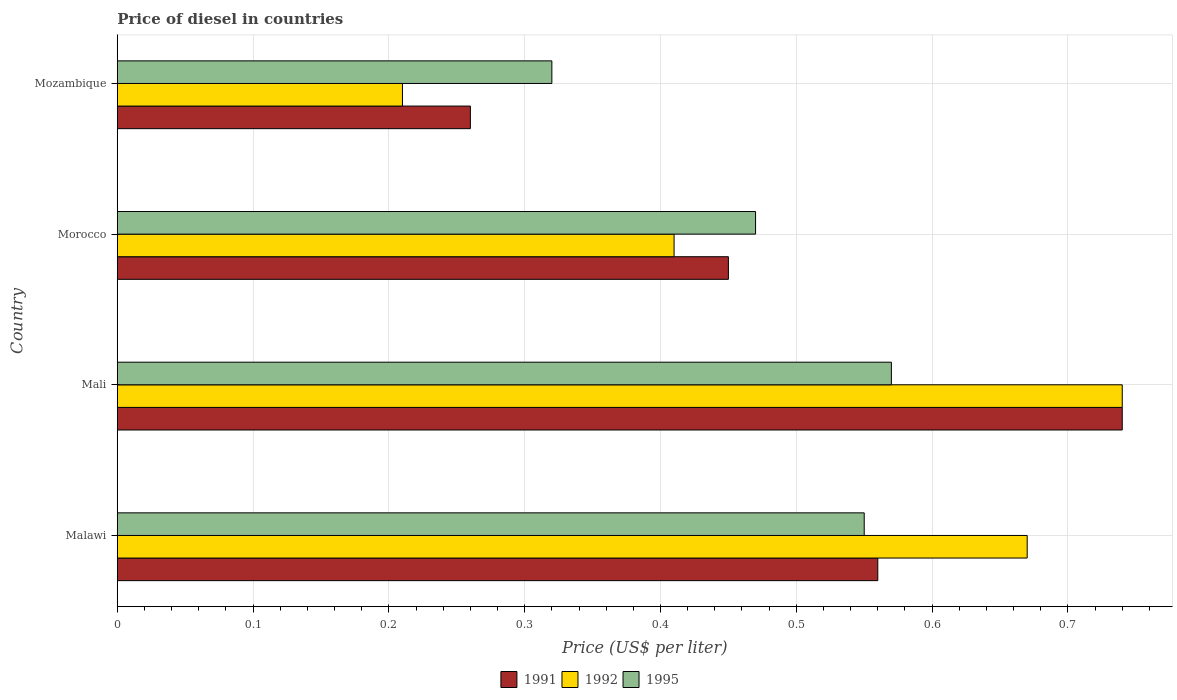Are the number of bars per tick equal to the number of legend labels?
Your answer should be compact. Yes. Are the number of bars on each tick of the Y-axis equal?
Your answer should be compact. Yes. How many bars are there on the 4th tick from the top?
Give a very brief answer. 3. What is the label of the 1st group of bars from the top?
Your answer should be compact. Mozambique. In how many cases, is the number of bars for a given country not equal to the number of legend labels?
Offer a terse response. 0. What is the price of diesel in 1995 in Malawi?
Give a very brief answer. 0.55. Across all countries, what is the maximum price of diesel in 1995?
Keep it short and to the point. 0.57. Across all countries, what is the minimum price of diesel in 1992?
Give a very brief answer. 0.21. In which country was the price of diesel in 1991 maximum?
Offer a very short reply. Mali. In which country was the price of diesel in 1995 minimum?
Ensure brevity in your answer.  Mozambique. What is the total price of diesel in 1992 in the graph?
Give a very brief answer. 2.03. What is the difference between the price of diesel in 1992 in Malawi and that in Morocco?
Your answer should be compact. 0.26. What is the difference between the price of diesel in 1991 in Morocco and the price of diesel in 1995 in Mozambique?
Give a very brief answer. 0.13. What is the average price of diesel in 1992 per country?
Your answer should be compact. 0.51. What is the difference between the price of diesel in 1992 and price of diesel in 1991 in Malawi?
Provide a succinct answer. 0.11. What is the ratio of the price of diesel in 1992 in Morocco to that in Mozambique?
Keep it short and to the point. 1.95. Is the price of diesel in 1995 in Morocco less than that in Mozambique?
Your response must be concise. No. What is the difference between the highest and the second highest price of diesel in 1995?
Ensure brevity in your answer.  0.02. What is the difference between the highest and the lowest price of diesel in 1991?
Offer a terse response. 0.48. In how many countries, is the price of diesel in 1995 greater than the average price of diesel in 1995 taken over all countries?
Offer a terse response. 2. Is the sum of the price of diesel in 1995 in Malawi and Morocco greater than the maximum price of diesel in 1992 across all countries?
Give a very brief answer. Yes. What does the 2nd bar from the top in Morocco represents?
Keep it short and to the point. 1992. What does the 1st bar from the bottom in Mozambique represents?
Provide a short and direct response. 1991. Is it the case that in every country, the sum of the price of diesel in 1991 and price of diesel in 1992 is greater than the price of diesel in 1995?
Offer a terse response. Yes. How many countries are there in the graph?
Keep it short and to the point. 4. Where does the legend appear in the graph?
Your response must be concise. Bottom center. How many legend labels are there?
Offer a very short reply. 3. What is the title of the graph?
Give a very brief answer. Price of diesel in countries. Does "1999" appear as one of the legend labels in the graph?
Offer a very short reply. No. What is the label or title of the X-axis?
Give a very brief answer. Price (US$ per liter). What is the label or title of the Y-axis?
Offer a terse response. Country. What is the Price (US$ per liter) of 1991 in Malawi?
Offer a terse response. 0.56. What is the Price (US$ per liter) of 1992 in Malawi?
Give a very brief answer. 0.67. What is the Price (US$ per liter) in 1995 in Malawi?
Your answer should be very brief. 0.55. What is the Price (US$ per liter) of 1991 in Mali?
Give a very brief answer. 0.74. What is the Price (US$ per liter) of 1992 in Mali?
Your response must be concise. 0.74. What is the Price (US$ per liter) in 1995 in Mali?
Offer a very short reply. 0.57. What is the Price (US$ per liter) in 1991 in Morocco?
Provide a succinct answer. 0.45. What is the Price (US$ per liter) of 1992 in Morocco?
Make the answer very short. 0.41. What is the Price (US$ per liter) of 1995 in Morocco?
Provide a succinct answer. 0.47. What is the Price (US$ per liter) in 1991 in Mozambique?
Ensure brevity in your answer.  0.26. What is the Price (US$ per liter) in 1992 in Mozambique?
Your answer should be compact. 0.21. What is the Price (US$ per liter) in 1995 in Mozambique?
Offer a very short reply. 0.32. Across all countries, what is the maximum Price (US$ per liter) in 1991?
Ensure brevity in your answer.  0.74. Across all countries, what is the maximum Price (US$ per liter) of 1992?
Your answer should be compact. 0.74. Across all countries, what is the maximum Price (US$ per liter) in 1995?
Provide a short and direct response. 0.57. Across all countries, what is the minimum Price (US$ per liter) in 1991?
Offer a very short reply. 0.26. Across all countries, what is the minimum Price (US$ per liter) of 1992?
Your answer should be very brief. 0.21. Across all countries, what is the minimum Price (US$ per liter) of 1995?
Keep it short and to the point. 0.32. What is the total Price (US$ per liter) in 1991 in the graph?
Offer a very short reply. 2.01. What is the total Price (US$ per liter) in 1992 in the graph?
Offer a very short reply. 2.03. What is the total Price (US$ per liter) of 1995 in the graph?
Your answer should be very brief. 1.91. What is the difference between the Price (US$ per liter) in 1991 in Malawi and that in Mali?
Offer a very short reply. -0.18. What is the difference between the Price (US$ per liter) in 1992 in Malawi and that in Mali?
Make the answer very short. -0.07. What is the difference between the Price (US$ per liter) in 1995 in Malawi and that in Mali?
Offer a terse response. -0.02. What is the difference between the Price (US$ per liter) of 1991 in Malawi and that in Morocco?
Your answer should be very brief. 0.11. What is the difference between the Price (US$ per liter) in 1992 in Malawi and that in Morocco?
Your answer should be compact. 0.26. What is the difference between the Price (US$ per liter) in 1995 in Malawi and that in Morocco?
Make the answer very short. 0.08. What is the difference between the Price (US$ per liter) in 1991 in Malawi and that in Mozambique?
Give a very brief answer. 0.3. What is the difference between the Price (US$ per liter) in 1992 in Malawi and that in Mozambique?
Your answer should be compact. 0.46. What is the difference between the Price (US$ per liter) of 1995 in Malawi and that in Mozambique?
Your answer should be compact. 0.23. What is the difference between the Price (US$ per liter) of 1991 in Mali and that in Morocco?
Your answer should be compact. 0.29. What is the difference between the Price (US$ per liter) of 1992 in Mali and that in Morocco?
Make the answer very short. 0.33. What is the difference between the Price (US$ per liter) of 1991 in Mali and that in Mozambique?
Make the answer very short. 0.48. What is the difference between the Price (US$ per liter) of 1992 in Mali and that in Mozambique?
Make the answer very short. 0.53. What is the difference between the Price (US$ per liter) in 1991 in Morocco and that in Mozambique?
Your response must be concise. 0.19. What is the difference between the Price (US$ per liter) in 1992 in Morocco and that in Mozambique?
Your response must be concise. 0.2. What is the difference between the Price (US$ per liter) of 1991 in Malawi and the Price (US$ per liter) of 1992 in Mali?
Your response must be concise. -0.18. What is the difference between the Price (US$ per liter) in 1991 in Malawi and the Price (US$ per liter) in 1995 in Mali?
Your answer should be very brief. -0.01. What is the difference between the Price (US$ per liter) in 1991 in Malawi and the Price (US$ per liter) in 1992 in Morocco?
Provide a succinct answer. 0.15. What is the difference between the Price (US$ per liter) of 1991 in Malawi and the Price (US$ per liter) of 1995 in Morocco?
Offer a very short reply. 0.09. What is the difference between the Price (US$ per liter) in 1992 in Malawi and the Price (US$ per liter) in 1995 in Morocco?
Give a very brief answer. 0.2. What is the difference between the Price (US$ per liter) of 1991 in Malawi and the Price (US$ per liter) of 1995 in Mozambique?
Offer a very short reply. 0.24. What is the difference between the Price (US$ per liter) of 1992 in Malawi and the Price (US$ per liter) of 1995 in Mozambique?
Provide a succinct answer. 0.35. What is the difference between the Price (US$ per liter) of 1991 in Mali and the Price (US$ per liter) of 1992 in Morocco?
Your response must be concise. 0.33. What is the difference between the Price (US$ per liter) in 1991 in Mali and the Price (US$ per liter) in 1995 in Morocco?
Offer a terse response. 0.27. What is the difference between the Price (US$ per liter) in 1992 in Mali and the Price (US$ per liter) in 1995 in Morocco?
Your answer should be very brief. 0.27. What is the difference between the Price (US$ per liter) in 1991 in Mali and the Price (US$ per liter) in 1992 in Mozambique?
Offer a terse response. 0.53. What is the difference between the Price (US$ per liter) in 1991 in Mali and the Price (US$ per liter) in 1995 in Mozambique?
Keep it short and to the point. 0.42. What is the difference between the Price (US$ per liter) of 1992 in Mali and the Price (US$ per liter) of 1995 in Mozambique?
Provide a succinct answer. 0.42. What is the difference between the Price (US$ per liter) of 1991 in Morocco and the Price (US$ per liter) of 1992 in Mozambique?
Your answer should be compact. 0.24. What is the difference between the Price (US$ per liter) in 1991 in Morocco and the Price (US$ per liter) in 1995 in Mozambique?
Offer a very short reply. 0.13. What is the difference between the Price (US$ per liter) of 1992 in Morocco and the Price (US$ per liter) of 1995 in Mozambique?
Your response must be concise. 0.09. What is the average Price (US$ per liter) of 1991 per country?
Offer a terse response. 0.5. What is the average Price (US$ per liter) of 1992 per country?
Ensure brevity in your answer.  0.51. What is the average Price (US$ per liter) of 1995 per country?
Give a very brief answer. 0.48. What is the difference between the Price (US$ per liter) of 1991 and Price (US$ per liter) of 1992 in Malawi?
Your answer should be compact. -0.11. What is the difference between the Price (US$ per liter) in 1992 and Price (US$ per liter) in 1995 in Malawi?
Offer a terse response. 0.12. What is the difference between the Price (US$ per liter) of 1991 and Price (US$ per liter) of 1992 in Mali?
Ensure brevity in your answer.  0. What is the difference between the Price (US$ per liter) of 1991 and Price (US$ per liter) of 1995 in Mali?
Ensure brevity in your answer.  0.17. What is the difference between the Price (US$ per liter) in 1992 and Price (US$ per liter) in 1995 in Mali?
Provide a short and direct response. 0.17. What is the difference between the Price (US$ per liter) of 1991 and Price (US$ per liter) of 1992 in Morocco?
Your answer should be very brief. 0.04. What is the difference between the Price (US$ per liter) in 1991 and Price (US$ per liter) in 1995 in Morocco?
Ensure brevity in your answer.  -0.02. What is the difference between the Price (US$ per liter) of 1992 and Price (US$ per liter) of 1995 in Morocco?
Provide a short and direct response. -0.06. What is the difference between the Price (US$ per liter) of 1991 and Price (US$ per liter) of 1995 in Mozambique?
Provide a short and direct response. -0.06. What is the difference between the Price (US$ per liter) of 1992 and Price (US$ per liter) of 1995 in Mozambique?
Keep it short and to the point. -0.11. What is the ratio of the Price (US$ per liter) in 1991 in Malawi to that in Mali?
Your answer should be compact. 0.76. What is the ratio of the Price (US$ per liter) of 1992 in Malawi to that in Mali?
Keep it short and to the point. 0.91. What is the ratio of the Price (US$ per liter) of 1995 in Malawi to that in Mali?
Offer a terse response. 0.96. What is the ratio of the Price (US$ per liter) in 1991 in Malawi to that in Morocco?
Give a very brief answer. 1.24. What is the ratio of the Price (US$ per liter) of 1992 in Malawi to that in Morocco?
Provide a short and direct response. 1.63. What is the ratio of the Price (US$ per liter) of 1995 in Malawi to that in Morocco?
Ensure brevity in your answer.  1.17. What is the ratio of the Price (US$ per liter) of 1991 in Malawi to that in Mozambique?
Offer a terse response. 2.15. What is the ratio of the Price (US$ per liter) in 1992 in Malawi to that in Mozambique?
Your answer should be very brief. 3.19. What is the ratio of the Price (US$ per liter) of 1995 in Malawi to that in Mozambique?
Give a very brief answer. 1.72. What is the ratio of the Price (US$ per liter) in 1991 in Mali to that in Morocco?
Your answer should be compact. 1.64. What is the ratio of the Price (US$ per liter) in 1992 in Mali to that in Morocco?
Give a very brief answer. 1.8. What is the ratio of the Price (US$ per liter) of 1995 in Mali to that in Morocco?
Your answer should be compact. 1.21. What is the ratio of the Price (US$ per liter) in 1991 in Mali to that in Mozambique?
Your response must be concise. 2.85. What is the ratio of the Price (US$ per liter) of 1992 in Mali to that in Mozambique?
Offer a terse response. 3.52. What is the ratio of the Price (US$ per liter) of 1995 in Mali to that in Mozambique?
Provide a short and direct response. 1.78. What is the ratio of the Price (US$ per liter) in 1991 in Morocco to that in Mozambique?
Give a very brief answer. 1.73. What is the ratio of the Price (US$ per liter) in 1992 in Morocco to that in Mozambique?
Your answer should be very brief. 1.95. What is the ratio of the Price (US$ per liter) of 1995 in Morocco to that in Mozambique?
Ensure brevity in your answer.  1.47. What is the difference between the highest and the second highest Price (US$ per liter) of 1991?
Provide a short and direct response. 0.18. What is the difference between the highest and the second highest Price (US$ per liter) in 1992?
Provide a short and direct response. 0.07. What is the difference between the highest and the lowest Price (US$ per liter) in 1991?
Offer a very short reply. 0.48. What is the difference between the highest and the lowest Price (US$ per liter) in 1992?
Ensure brevity in your answer.  0.53. What is the difference between the highest and the lowest Price (US$ per liter) in 1995?
Offer a very short reply. 0.25. 